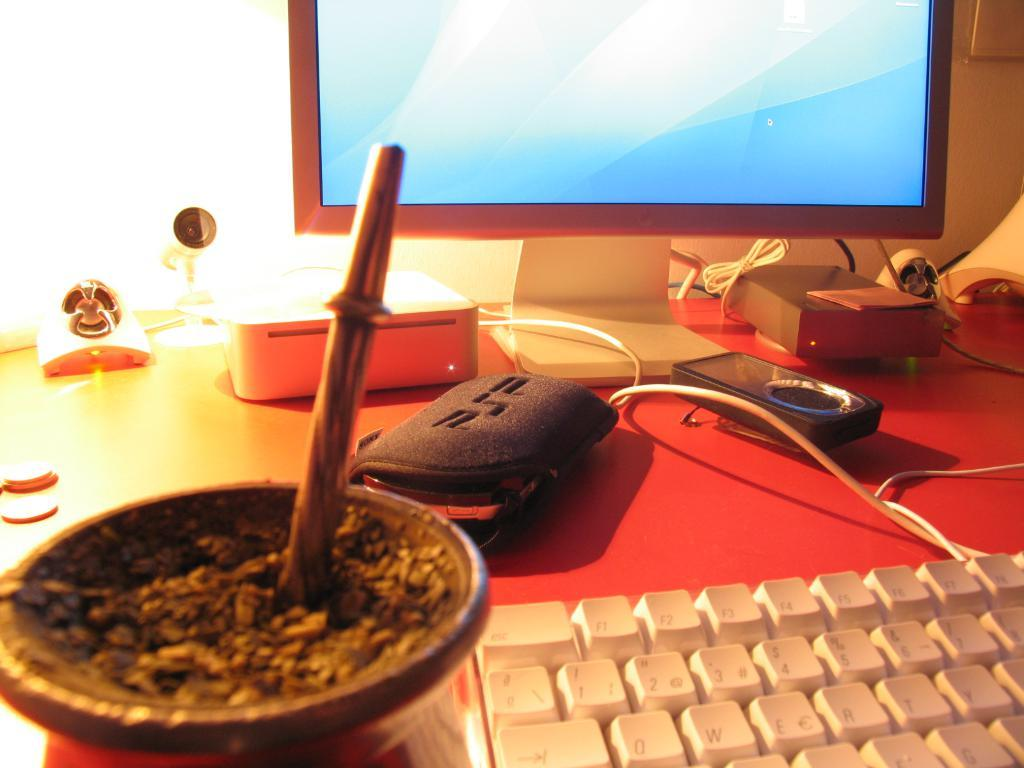What type of furniture is in the image? There is a table in the image. What electronic device is on the table? A keyboard is present on the table. What else can be seen on the table? Cables, a bowl, a monitor, and other objects are visible on the table. What is behind the monitor in the image? There is a wall behind the monitor. What type of punishment is being administered to the farm animals in the image? There are no farm animals or any indication of punishment in the image. 